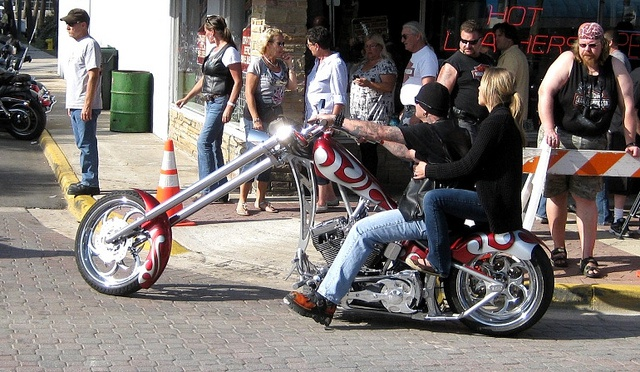Describe the objects in this image and their specific colors. I can see motorcycle in gray, black, darkgray, and white tones, people in gray, black, brown, white, and maroon tones, people in gray, black, navy, and darkblue tones, people in gray, black, white, and darkgray tones, and people in gray, black, white, and darkgray tones in this image. 